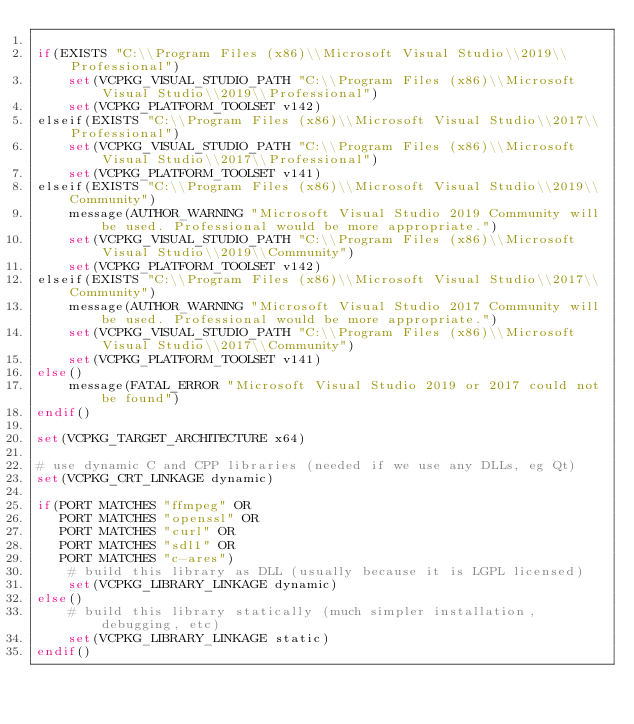<code> <loc_0><loc_0><loc_500><loc_500><_CMake_>
if(EXISTS "C:\\Program Files (x86)\\Microsoft Visual Studio\\2019\\Professional")
    set(VCPKG_VISUAL_STUDIO_PATH "C:\\Program Files (x86)\\Microsoft Visual Studio\\2019\\Professional")
    set(VCPKG_PLATFORM_TOOLSET v142)
elseif(EXISTS "C:\\Program Files (x86)\\Microsoft Visual Studio\\2017\\Professional")
    set(VCPKG_VISUAL_STUDIO_PATH "C:\\Program Files (x86)\\Microsoft Visual Studio\\2017\\Professional")
    set(VCPKG_PLATFORM_TOOLSET v141)
elseif(EXISTS "C:\\Program Files (x86)\\Microsoft Visual Studio\\2019\\Community")
    message(AUTHOR_WARNING "Microsoft Visual Studio 2019 Community will be used. Professional would be more appropriate.")
    set(VCPKG_VISUAL_STUDIO_PATH "C:\\Program Files (x86)\\Microsoft Visual Studio\\2019\\Community")
    set(VCPKG_PLATFORM_TOOLSET v142)
elseif(EXISTS "C:\\Program Files (x86)\\Microsoft Visual Studio\\2017\\Community")
    message(AUTHOR_WARNING "Microsoft Visual Studio 2017 Community will be used. Professional would be more appropriate.")
    set(VCPKG_VISUAL_STUDIO_PATH "C:\\Program Files (x86)\\Microsoft Visual Studio\\2017\\Community")
    set(VCPKG_PLATFORM_TOOLSET v141)
else()
    message(FATAL_ERROR "Microsoft Visual Studio 2019 or 2017 could not be found")
endif()

set(VCPKG_TARGET_ARCHITECTURE x64)

# use dynamic C and CPP libraries (needed if we use any DLLs, eg Qt)
set(VCPKG_CRT_LINKAGE dynamic)

if(PORT MATCHES "ffmpeg" OR
   PORT MATCHES "openssl" OR
   PORT MATCHES "curl" OR
   PORT MATCHES "sdl1" OR
   PORT MATCHES "c-ares")
    # build this library as DLL (usually because it is LGPL licensed)
    set(VCPKG_LIBRARY_LINKAGE dynamic)
else()
    # build this library statically (much simpler installation, debugging, etc)
    set(VCPKG_LIBRARY_LINKAGE static)
endif()
</code> 